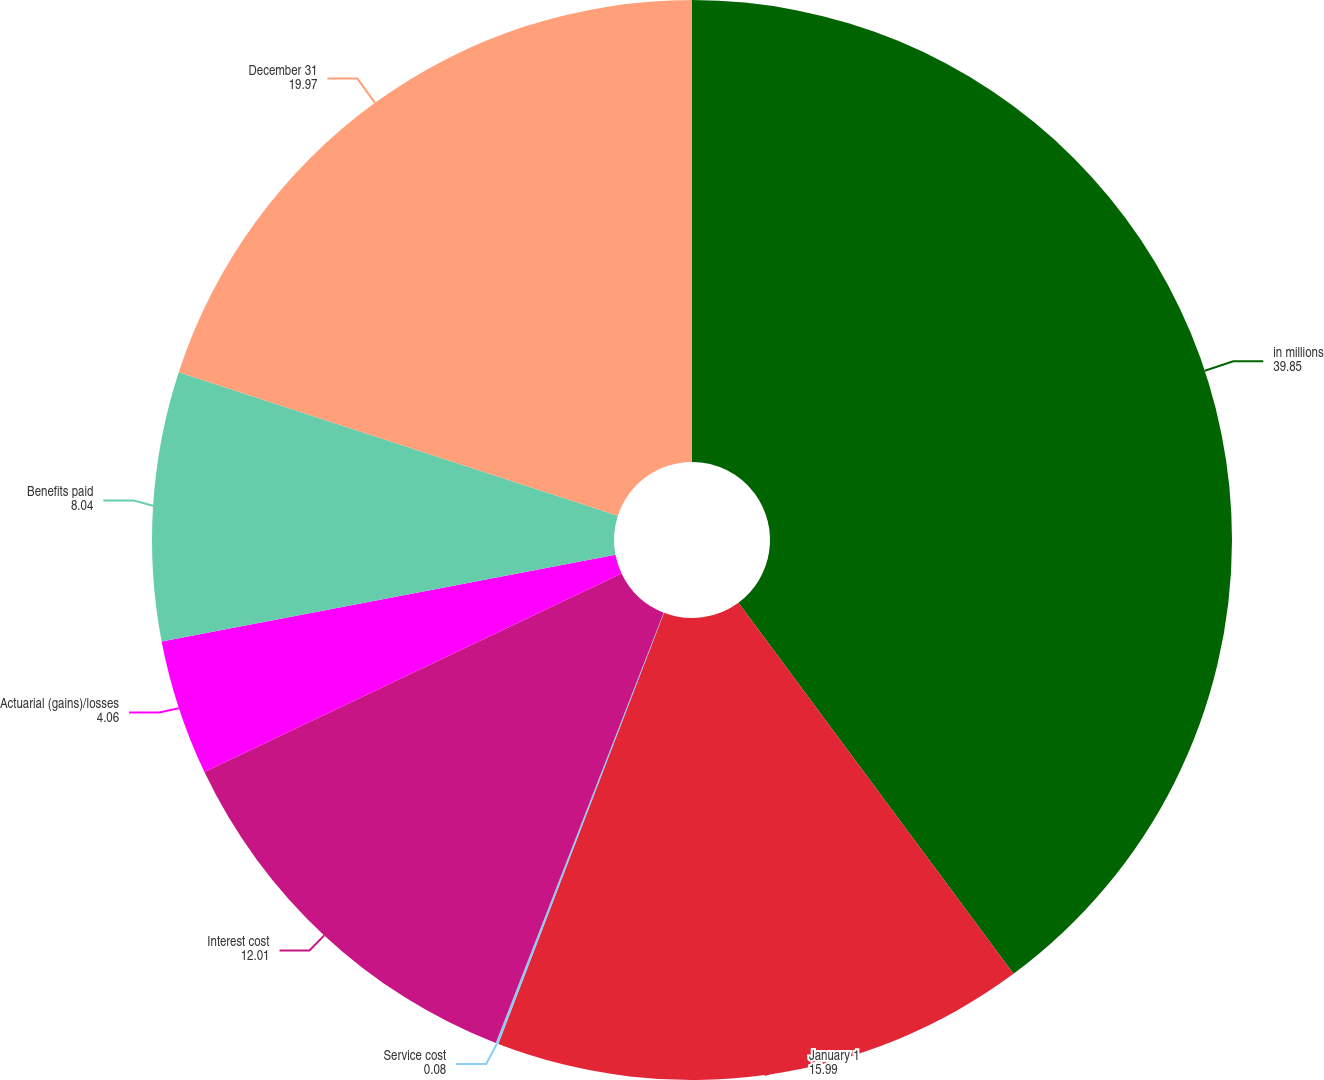Convert chart to OTSL. <chart><loc_0><loc_0><loc_500><loc_500><pie_chart><fcel>in millions<fcel>January 1<fcel>Service cost<fcel>Interest cost<fcel>Actuarial (gains)/losses<fcel>Benefits paid<fcel>December 31<nl><fcel>39.85%<fcel>15.99%<fcel>0.08%<fcel>12.01%<fcel>4.06%<fcel>8.04%<fcel>19.97%<nl></chart> 